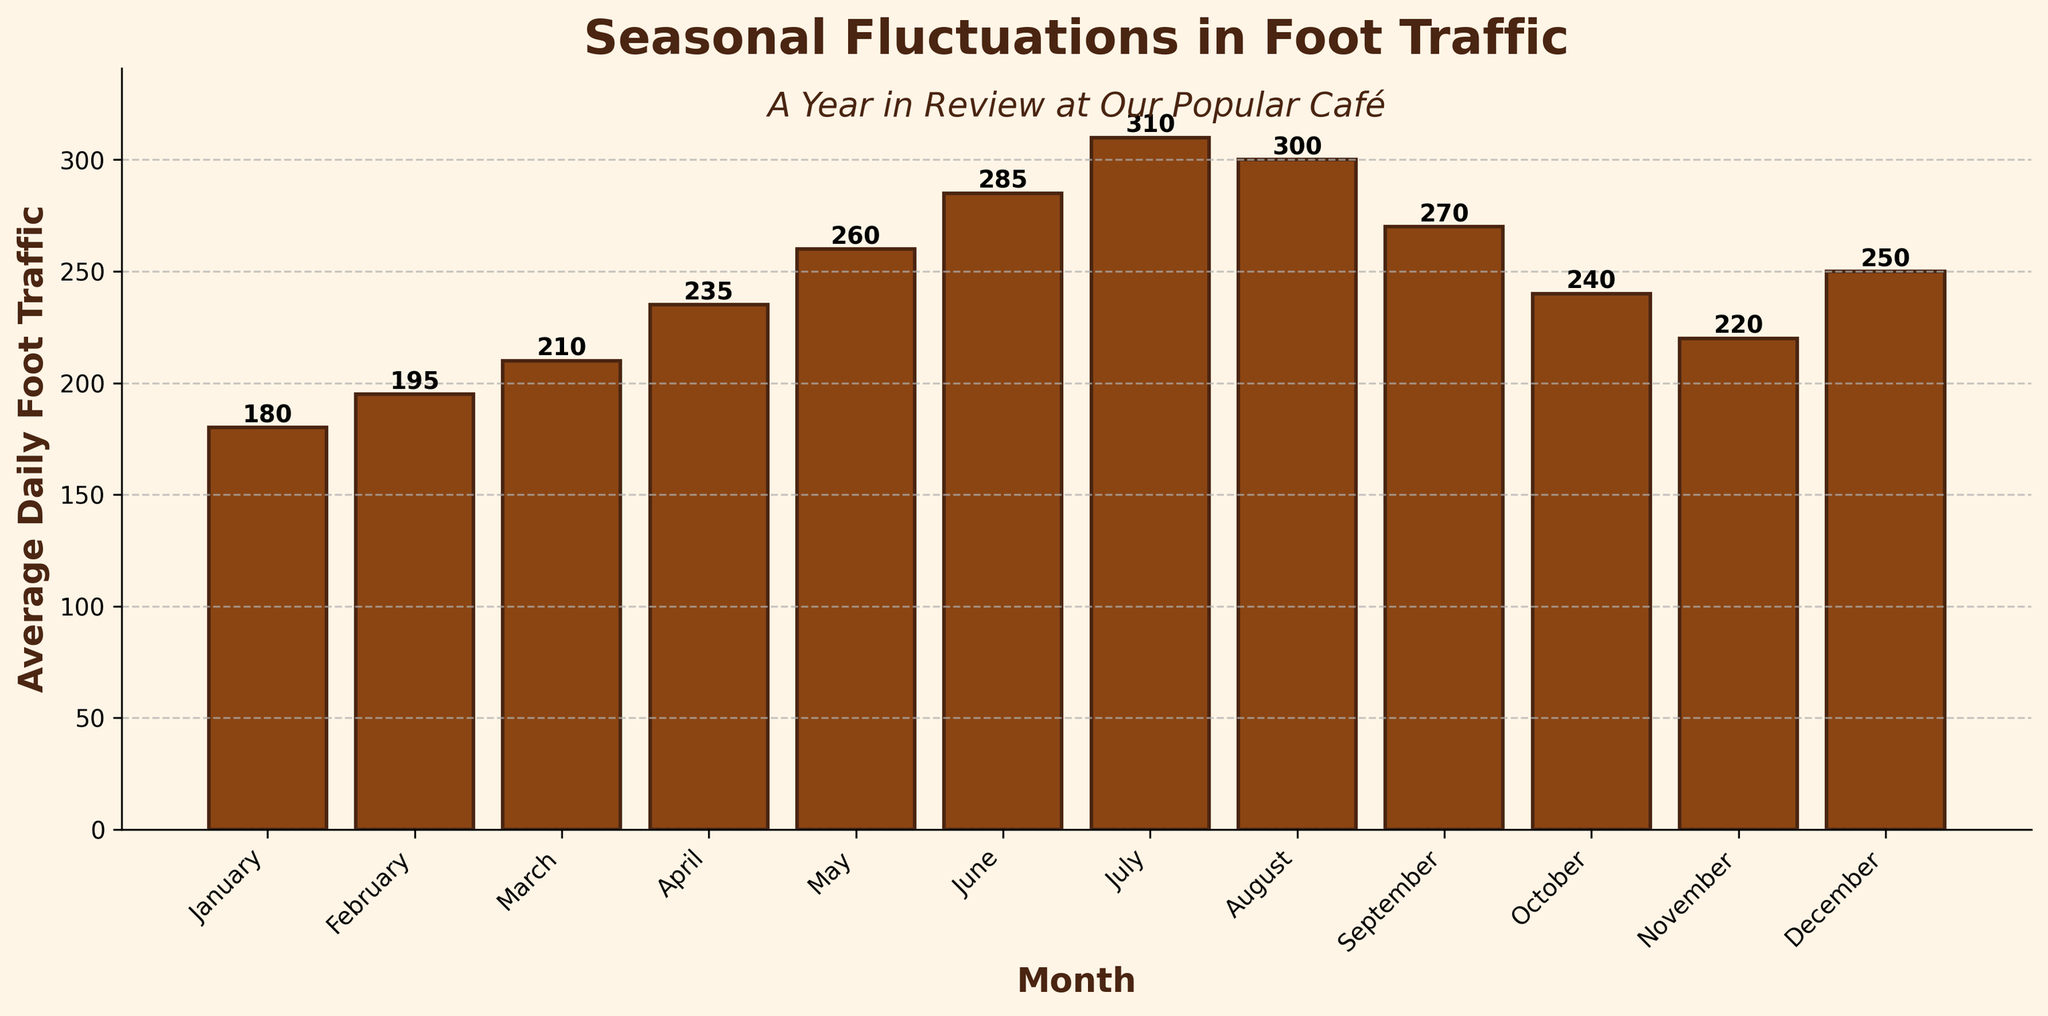What is the month with the highest foot traffic? By observing the height of the bars in the bar chart, the tallest bar represents the month with the highest foot traffic which is July.
Answer: July Which months have foot traffic greater than 250? Check the heights of the bars that exceed the value of 250 on the y-axis. These months are May, June, July, August, and December.
Answer: May, June, July, August, December What is the decrease in foot traffic from July to August? By comparing the heights of the bars for July and August, subtract the foot traffic of August (300) from that of July (310), the decrease is 10.
Answer: 10 How much higher is the foot traffic in June compared to January? Compare the heights of the bars for June and January. June has 285 while January has 180. Subtract 180 from 285, giving a difference of 105.
Answer: 105 Which month has the smallest increase in foot traffic compared to the previous month? Compare the differences between consecutive months by observing bar heights. The smallest increase is from November (220) to December (250), with an increase of 30.
Answer: December What is the average foot traffic for the first six months? Sum the foot traffic values for January through June and divide by 6: (180 + 195 + 210 + 235 + 260 + 285) / 6 = 228.33.
Answer: 228.33 Is August foot traffic greater than June and July combined? Compare the bar heights, the sum of June (285) and July (310) is 595, which is greater than August (300).
Answer: No Which month has the lowest foot traffic? Search for the shortest bar which represents the month with the lowest foot traffic, which is January.
Answer: January Which has greater foot traffic, spring (March-May) or fall (September-November)? Sum the traffic in spring (210 + 235 + 260 = 705) and fall (270 + 240 + 220 = 730). Compare these sums, fall has higher traffic.
Answer: Fall What is the median foot traffic for the year? List the values in ascending order: (180, 195, 210, 220, 235, 240, 250, 260, 270, 285, 300, 310). The median is the average of the 6th and 7th values: (240 + 250) / 2 = 245.
Answer: 245 